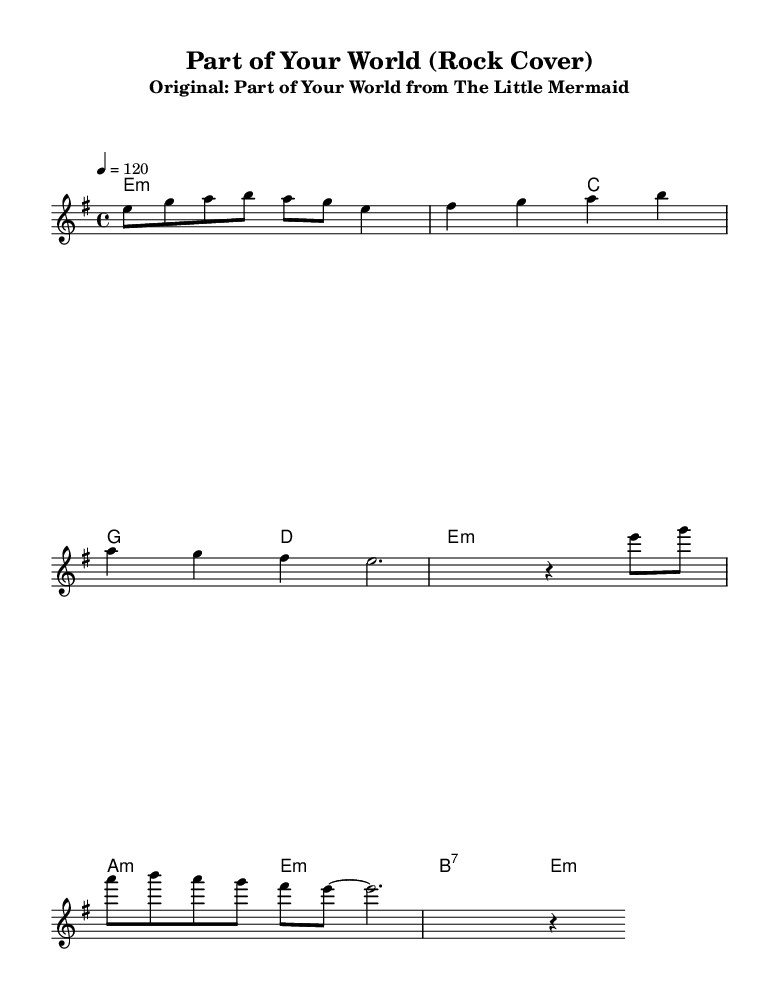What is the key signature of this music? The key signature indicates E minor, which is represented by one sharp (F#) in the key signature. We can identify this by looking at the key indicated at the beginning of the score.
Answer: E minor What is the time signature of the piece? The time signature at the beginning of the score is 4/4, meaning there are four beats in every measure and the quarter note gets one beat. This is indicated by the notation right after the key signature at the beginning of the score.
Answer: 4/4 What is the tempo marking provided in the music? The tempo marking is 120, which indicates the beats per minute. This is shown in the score as a tempo directive following the time signature.
Answer: 120 Which chord is played at the beginning of the piece? The first chord in the score is an E minor chord, as indicated in the harmonies section. It is shown with the designation 'e1:m’ at the start of the piece.
Answer: E minor How many measures are there in the verse? The verse consists of two lines with a total of 4 measures, as we can count each section of the melody written for the verse. Each line contains two measures.
Answer: 4 What is the first note of the chorus? The first note of the chorus is E, which is indicated as the starting note in the melody section labeled under the chorus. This is where the melody for the chorus begins.
Answer: E What type of chord is used in the chorus? The chords in the chorus include D minor and E minor, followed by B7 and E minor, as indicated in the harmonies section showing various chord progressions.
Answer: Minor 